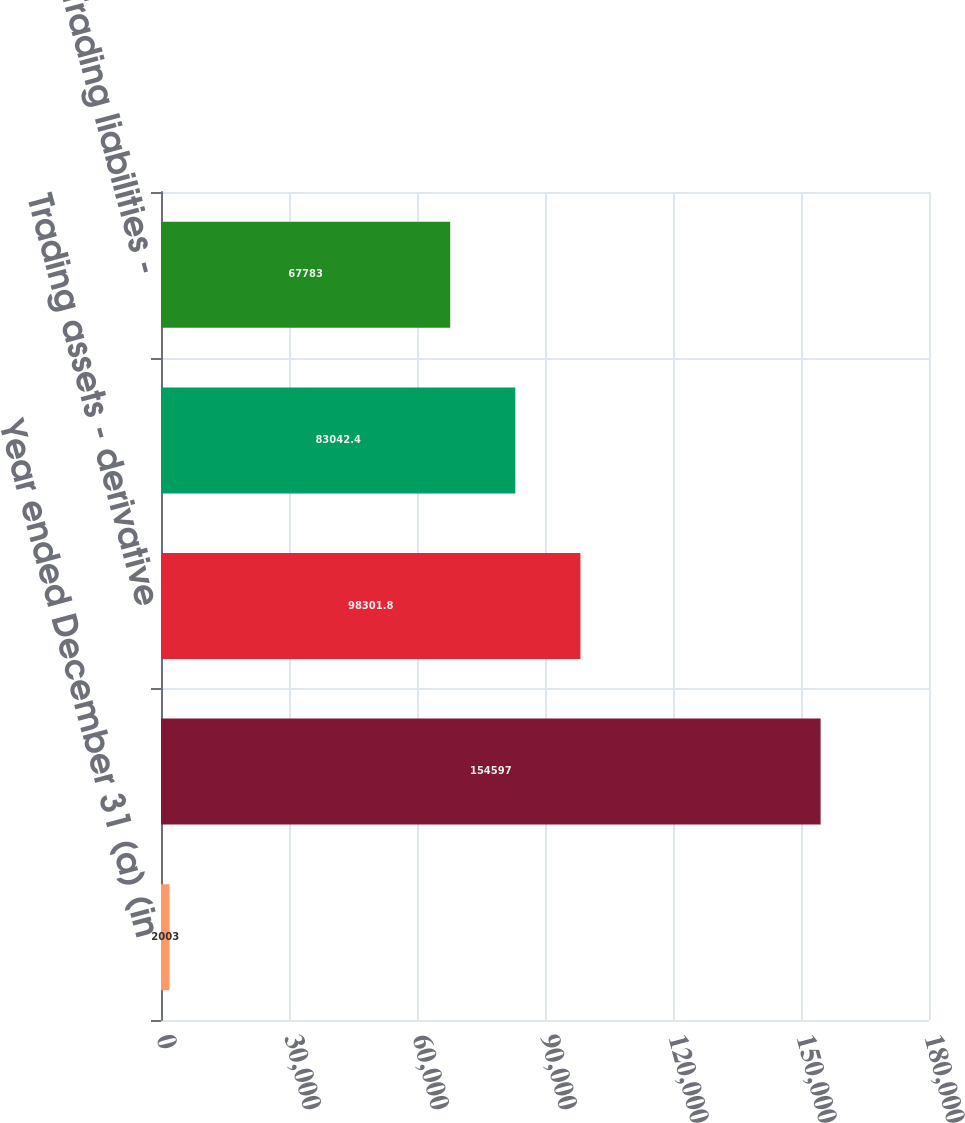Convert chart to OTSL. <chart><loc_0><loc_0><loc_500><loc_500><bar_chart><fcel>Year ended December 31 (a) (in<fcel>Trading assets - debt and<fcel>Trading assets - derivative<fcel>Trading liabilities - debt and<fcel>Trading liabilities -<nl><fcel>2003<fcel>154597<fcel>98301.8<fcel>83042.4<fcel>67783<nl></chart> 